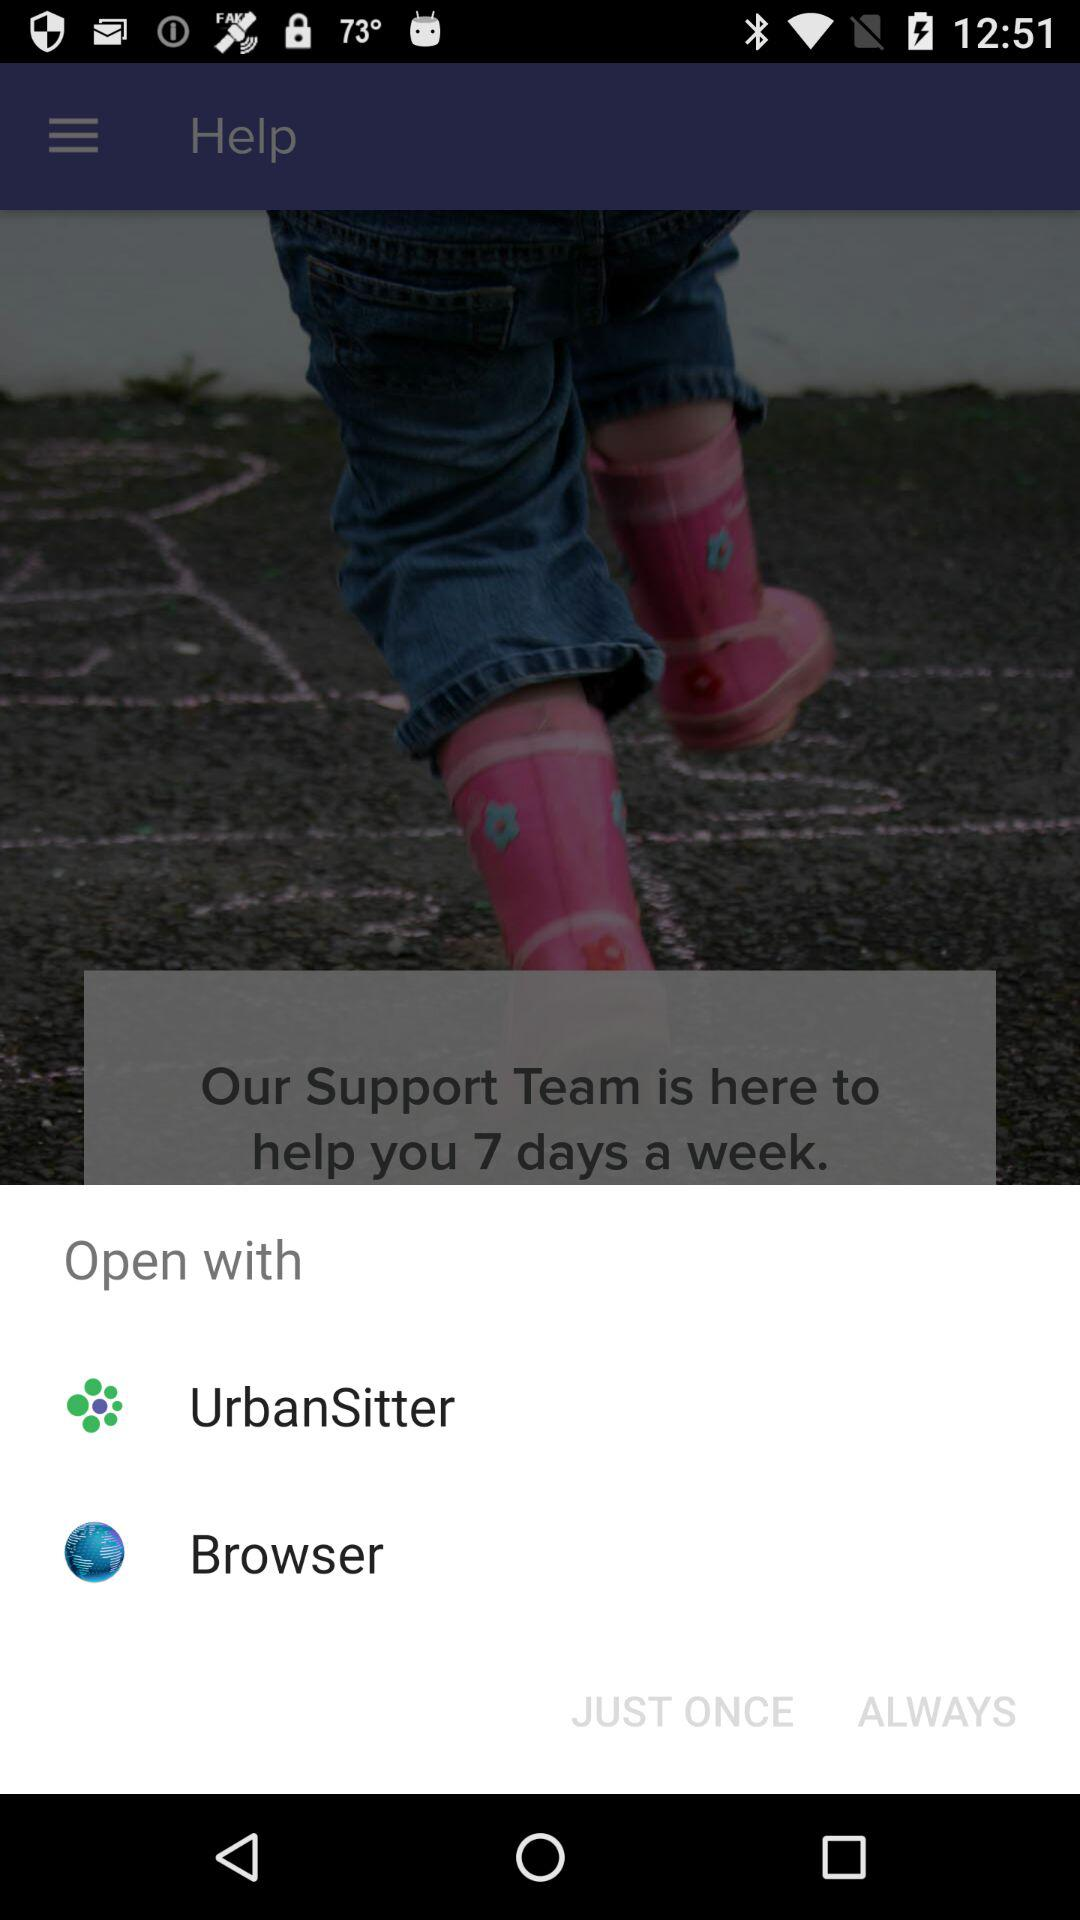What are the options to open with? The options to open with are "UrbanSitter" and "Browser". 